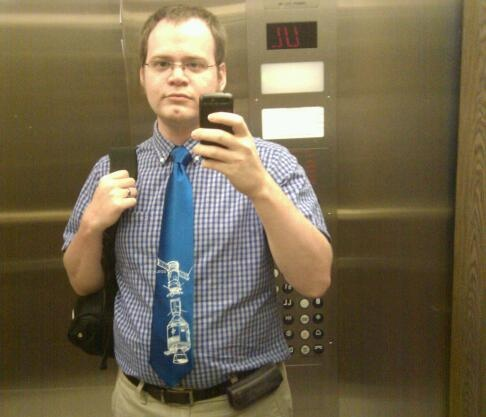Describe the objects in this image and their specific colors. I can see people in tan, gray, darkgray, and black tones, tie in tan, teal, navy, blue, and gray tones, handbag in tan, black, and gray tones, backpack in tan, black, and gray tones, and cell phone in tan, black, and gray tones in this image. 